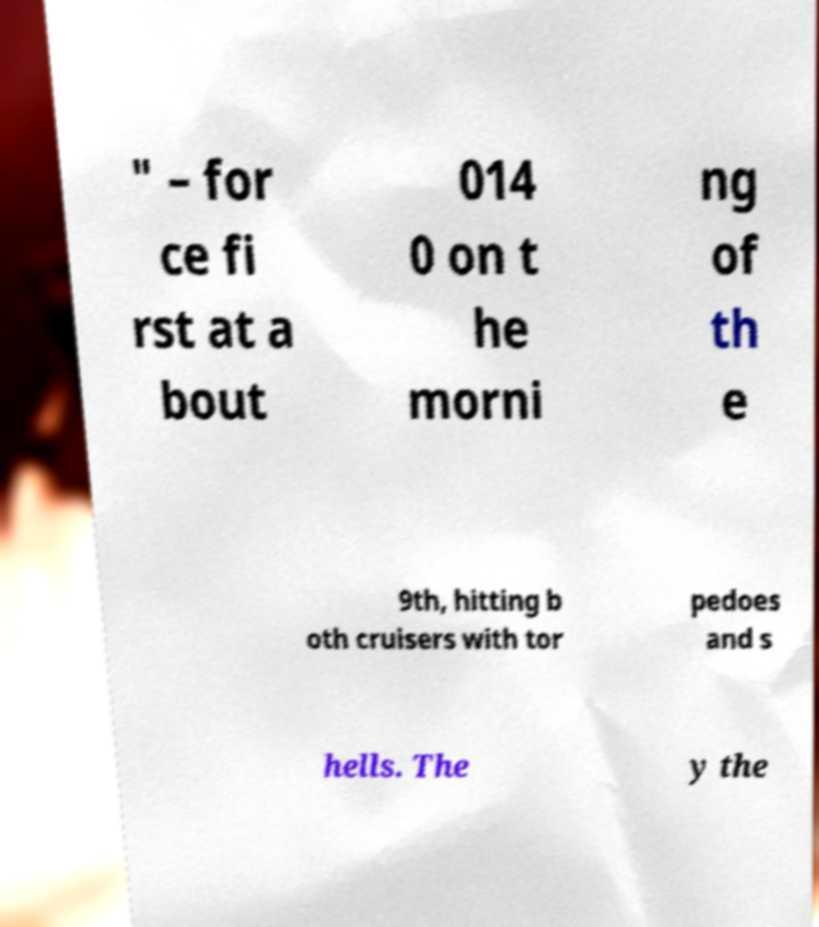I need the written content from this picture converted into text. Can you do that? " – for ce fi rst at a bout 014 0 on t he morni ng of th e 9th, hitting b oth cruisers with tor pedoes and s hells. The y the 